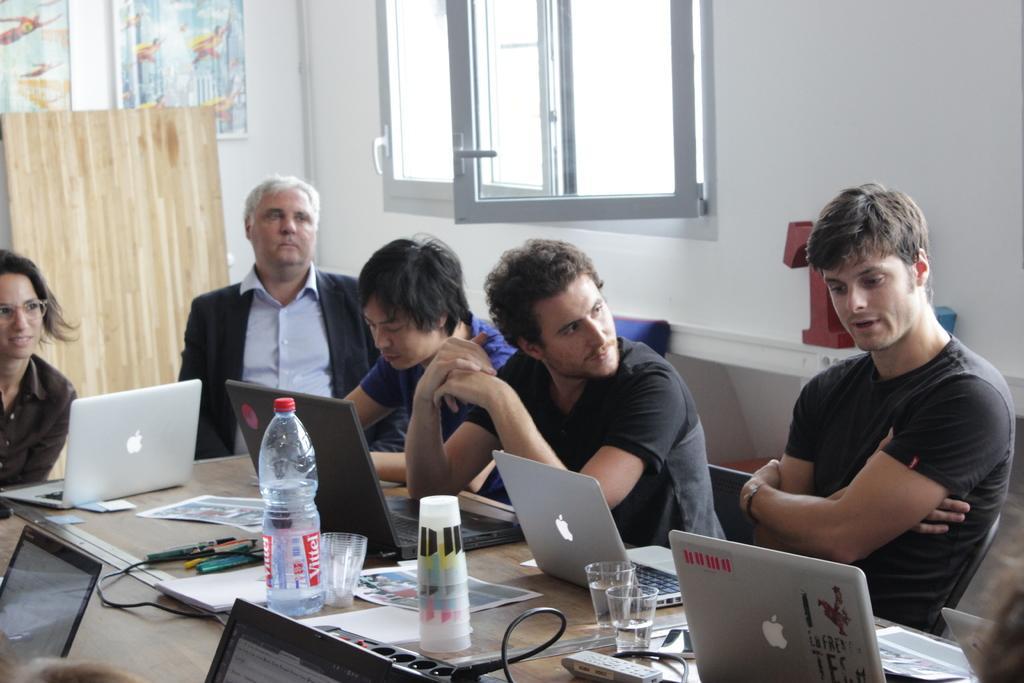Can you describe this image briefly? In the foreground of the image, there are five people sitting on the chair in front of the table, on which laptop, bottle, glass, pen, pencil, wires and son kept. In the background, there is a wall of white in color and a window visible. In the left, wall painting is there. This image is taken inside a office campus. 